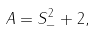<formula> <loc_0><loc_0><loc_500><loc_500>A = S _ { - } ^ { 2 } + 2 ,</formula> 